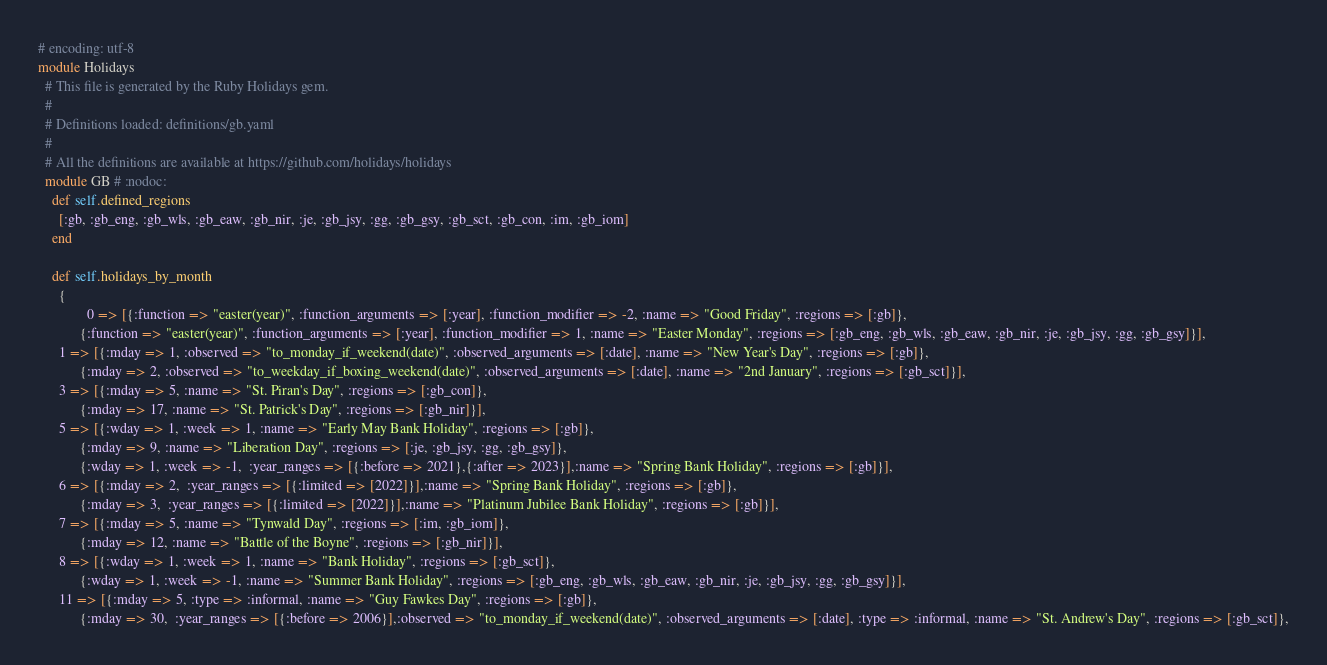Convert code to text. <code><loc_0><loc_0><loc_500><loc_500><_Ruby_># encoding: utf-8
module Holidays
  # This file is generated by the Ruby Holidays gem.
  #
  # Definitions loaded: definitions/gb.yaml
  #
  # All the definitions are available at https://github.com/holidays/holidays
  module GB # :nodoc:
    def self.defined_regions
      [:gb, :gb_eng, :gb_wls, :gb_eaw, :gb_nir, :je, :gb_jsy, :gg, :gb_gsy, :gb_sct, :gb_con, :im, :gb_iom]
    end

    def self.holidays_by_month
      {
              0 => [{:function => "easter(year)", :function_arguments => [:year], :function_modifier => -2, :name => "Good Friday", :regions => [:gb]},
            {:function => "easter(year)", :function_arguments => [:year], :function_modifier => 1, :name => "Easter Monday", :regions => [:gb_eng, :gb_wls, :gb_eaw, :gb_nir, :je, :gb_jsy, :gg, :gb_gsy]}],
      1 => [{:mday => 1, :observed => "to_monday_if_weekend(date)", :observed_arguments => [:date], :name => "New Year's Day", :regions => [:gb]},
            {:mday => 2, :observed => "to_weekday_if_boxing_weekend(date)", :observed_arguments => [:date], :name => "2nd January", :regions => [:gb_sct]}],
      3 => [{:mday => 5, :name => "St. Piran's Day", :regions => [:gb_con]},
            {:mday => 17, :name => "St. Patrick's Day", :regions => [:gb_nir]}],
      5 => [{:wday => 1, :week => 1, :name => "Early May Bank Holiday", :regions => [:gb]},
            {:mday => 9, :name => "Liberation Day", :regions => [:je, :gb_jsy, :gg, :gb_gsy]},
            {:wday => 1, :week => -1,  :year_ranges => [{:before => 2021},{:after => 2023}],:name => "Spring Bank Holiday", :regions => [:gb]}],
      6 => [{:mday => 2,  :year_ranges => [{:limited => [2022]}],:name => "Spring Bank Holiday", :regions => [:gb]},
            {:mday => 3,  :year_ranges => [{:limited => [2022]}],:name => "Platinum Jubilee Bank Holiday", :regions => [:gb]}],
      7 => [{:mday => 5, :name => "Tynwald Day", :regions => [:im, :gb_iom]},
            {:mday => 12, :name => "Battle of the Boyne", :regions => [:gb_nir]}],
      8 => [{:wday => 1, :week => 1, :name => "Bank Holiday", :regions => [:gb_sct]},
            {:wday => 1, :week => -1, :name => "Summer Bank Holiday", :regions => [:gb_eng, :gb_wls, :gb_eaw, :gb_nir, :je, :gb_jsy, :gg, :gb_gsy]}],
      11 => [{:mday => 5, :type => :informal, :name => "Guy Fawkes Day", :regions => [:gb]},
            {:mday => 30,  :year_ranges => [{:before => 2006}],:observed => "to_monday_if_weekend(date)", :observed_arguments => [:date], :type => :informal, :name => "St. Andrew's Day", :regions => [:gb_sct]},</code> 